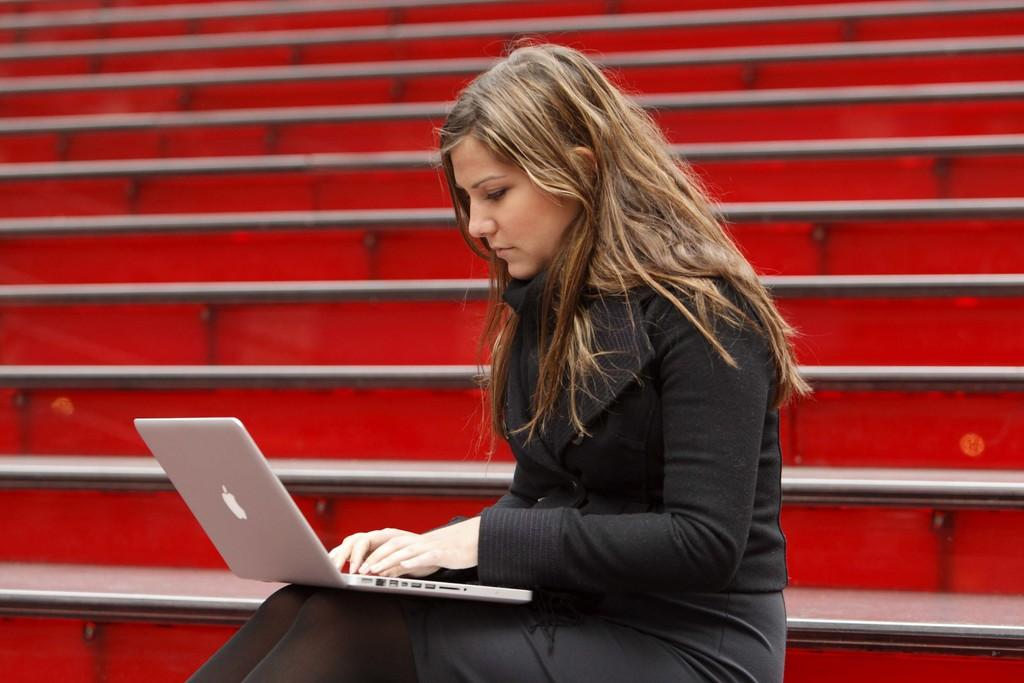Who is the main subject in the image? There is a woman in the image. Where is the woman located in the image? The woman is sitting on a staircase. What is the woman doing in the image? The woman is looking at a laptop. Can you describe the position of the laptop in the image? There is a laptop on the woman's lap. What type of creature can be seen on the ground in the image? There is no creature present on the ground in the image. What account does the woman have open on her laptop? The image does not provide information about the specific account or activity on the laptop. 